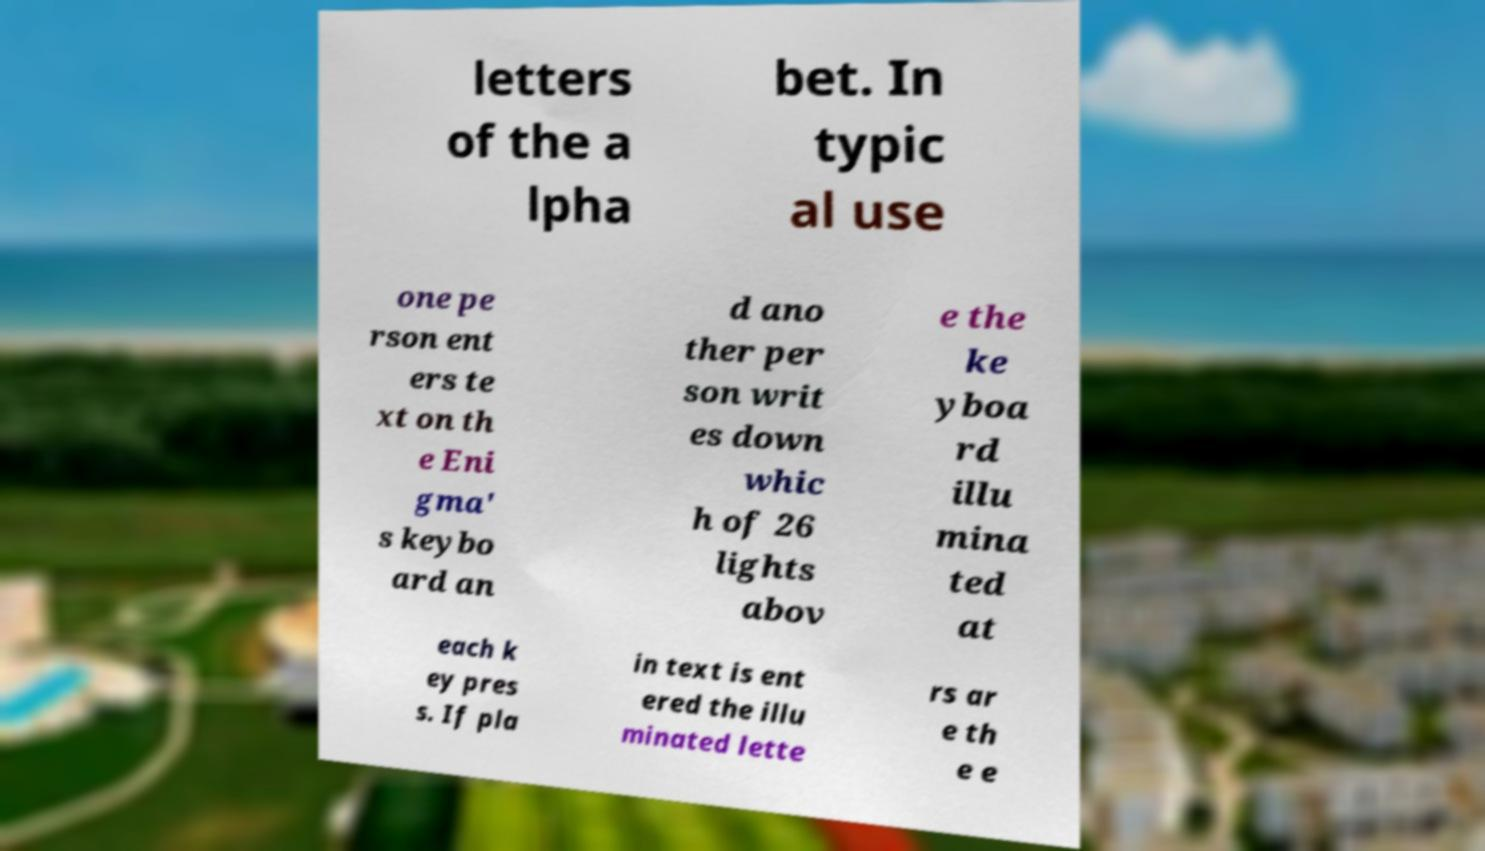Can you accurately transcribe the text from the provided image for me? letters of the a lpha bet. In typic al use one pe rson ent ers te xt on th e Eni gma' s keybo ard an d ano ther per son writ es down whic h of 26 lights abov e the ke yboa rd illu mina ted at each k ey pres s. If pla in text is ent ered the illu minated lette rs ar e th e e 